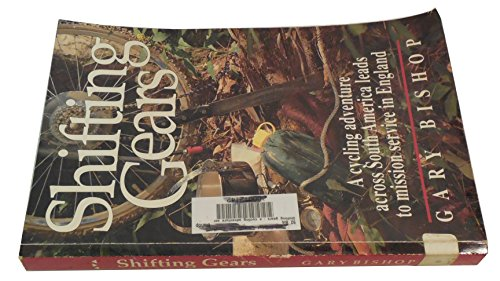Can you describe the setting depicted on the book cover? The book cover shows a colorful and detailed scene of a cycle journey. It's set in an outdoor environment, possibly within a dense forest or jungle pathway, highlighted by the presence of rich green foliage and rugged terrain, suggesting an adventurous spirit. 